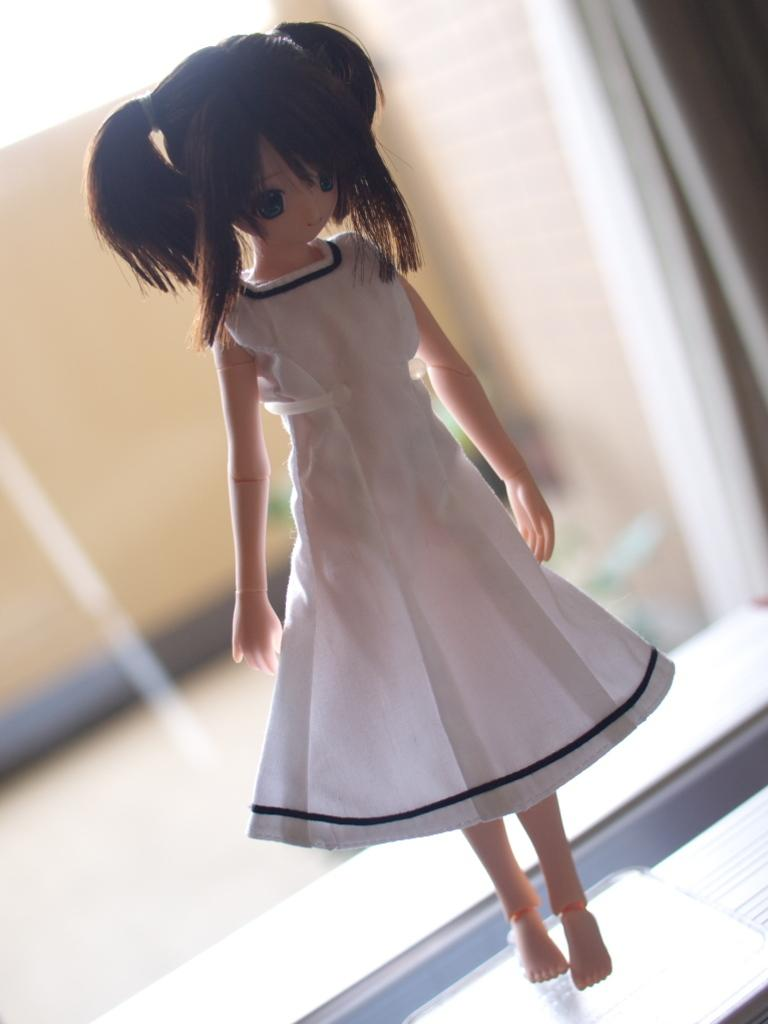What is the main subject of the image? There is a doll in the image. What is the doll wearing? The doll is wearing a white dress. Can you describe the quality of the image? The image is slightly blurry in the background. How many cows are jumping in the background of the image? There are no cows or jumping animals present in the image; it features a doll wearing a white dress. 